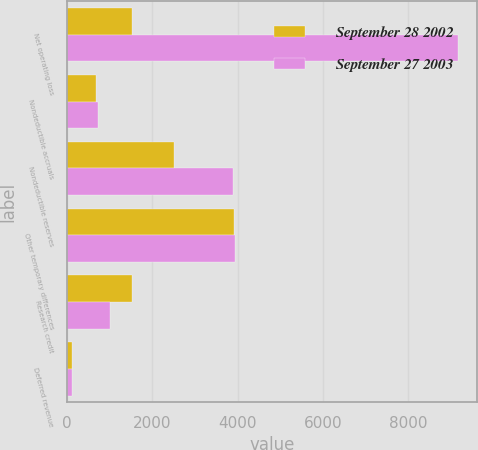Convert chart to OTSL. <chart><loc_0><loc_0><loc_500><loc_500><stacked_bar_chart><ecel><fcel>Net operating loss<fcel>Nondeductible accruals<fcel>Nondeductible reserves<fcel>Other temporary differences<fcel>Research credit<fcel>Deferred revenue<nl><fcel>September 28 2002<fcel>1509<fcel>684<fcel>2497<fcel>3910<fcel>1509<fcel>116<nl><fcel>September 27 2003<fcel>9167<fcel>720<fcel>3883<fcel>3935<fcel>1008<fcel>109<nl></chart> 